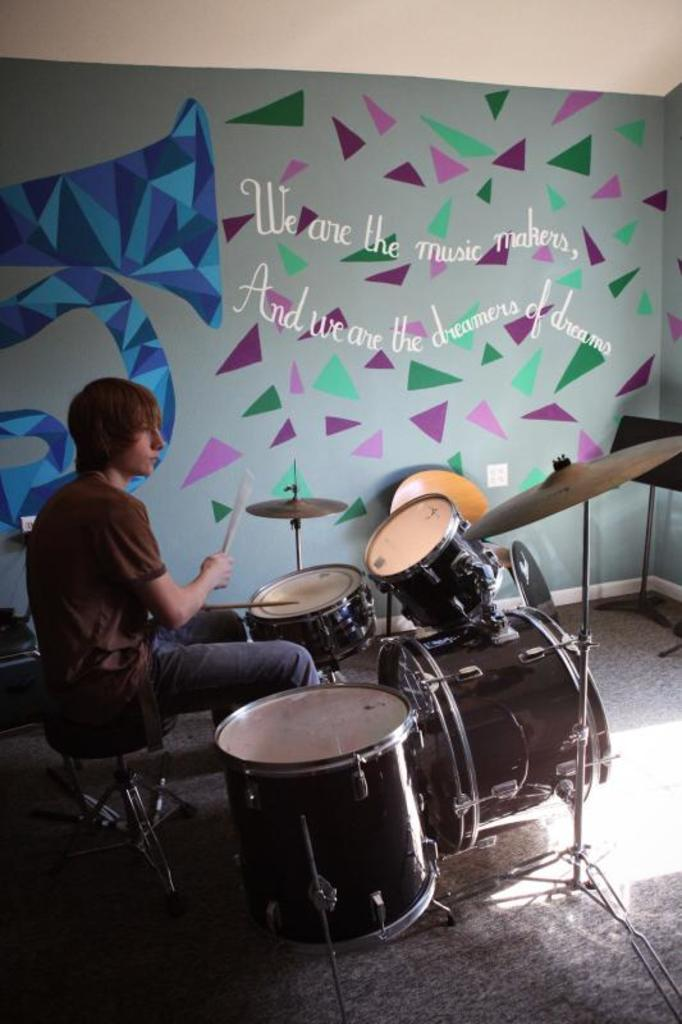What is the main subject of the image? The main subject of the image is a person sitting. What is the person doing in the image? The person is playing musical instruments. What can be seen in the background of the image? The background of the image includes a multicolored wall. Can you tell me how many women are playing the corn in the image? There are no women or corn present in the image; it features a person playing musical instruments in front of a multicolored wall. 